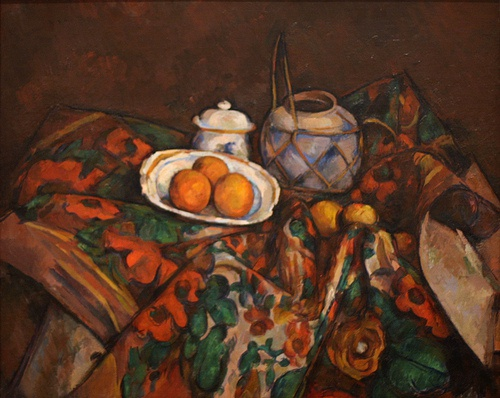Describe the objects in this image and their specific colors. I can see bowl in black, red, tan, and brown tones and orange in black, red, brown, orange, and maroon tones in this image. 